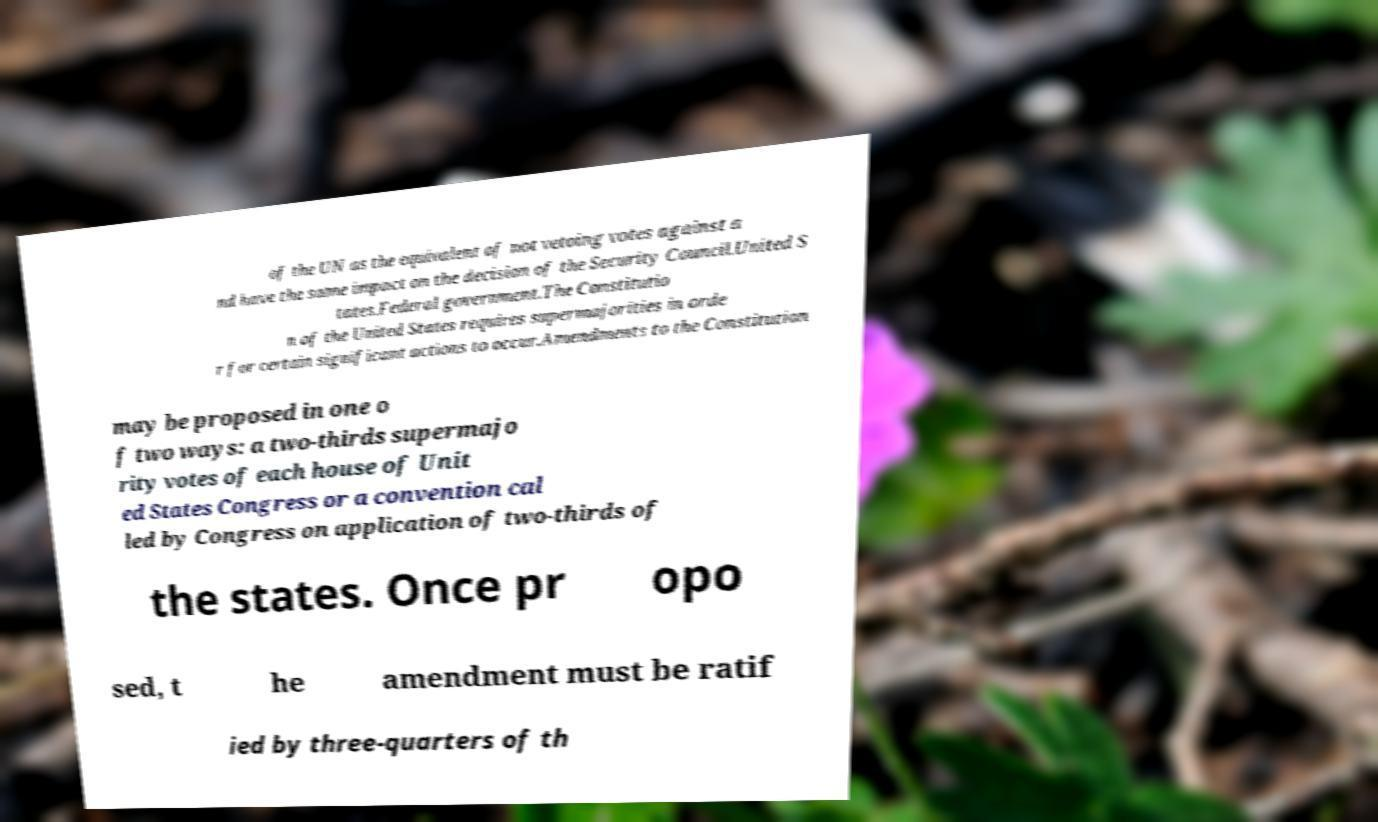Could you extract and type out the text from this image? of the UN as the equivalent of not vetoing votes against a nd have the same impact on the decision of the Security Council.United S tates.Federal government.The Constitutio n of the United States requires supermajorities in orde r for certain significant actions to occur.Amendments to the Constitution may be proposed in one o f two ways: a two-thirds supermajo rity votes of each house of Unit ed States Congress or a convention cal led by Congress on application of two-thirds of the states. Once pr opo sed, t he amendment must be ratif ied by three-quarters of th 